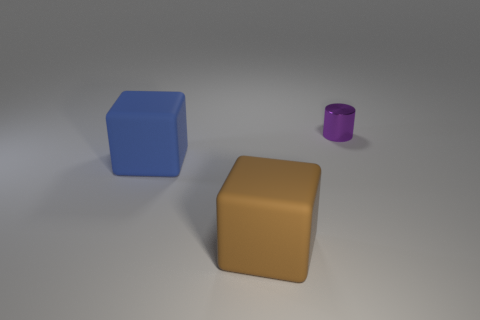Add 3 small things. How many objects exist? 6 Subtract all cylinders. How many objects are left? 2 Subtract all big brown metal balls. Subtract all big matte things. How many objects are left? 1 Add 3 small purple things. How many small purple things are left? 4 Add 3 big rubber things. How many big rubber things exist? 5 Subtract 0 gray blocks. How many objects are left? 3 